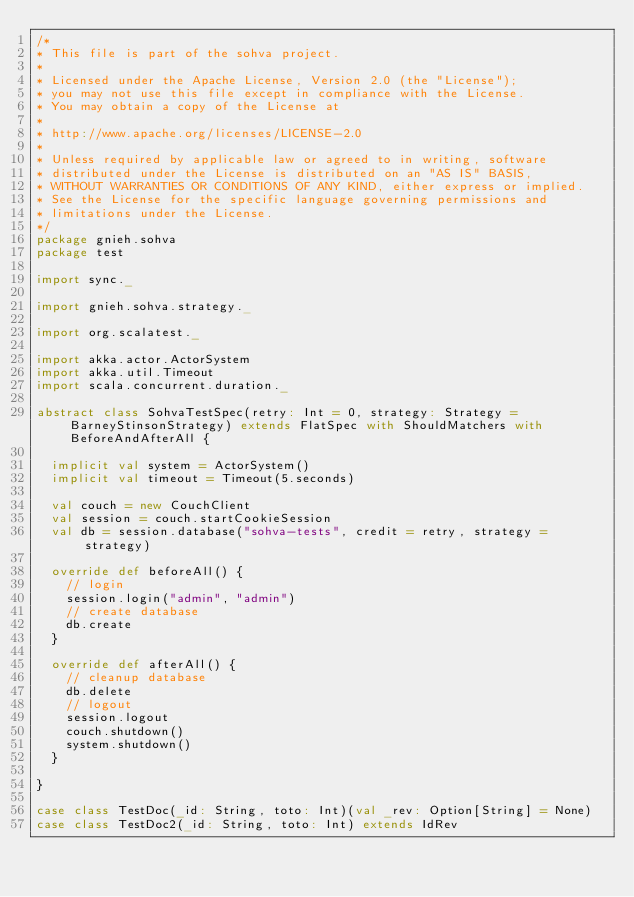Convert code to text. <code><loc_0><loc_0><loc_500><loc_500><_Scala_>/*
* This file is part of the sohva project.
*
* Licensed under the Apache License, Version 2.0 (the "License");
* you may not use this file except in compliance with the License.
* You may obtain a copy of the License at
*
* http://www.apache.org/licenses/LICENSE-2.0
*
* Unless required by applicable law or agreed to in writing, software
* distributed under the License is distributed on an "AS IS" BASIS,
* WITHOUT WARRANTIES OR CONDITIONS OF ANY KIND, either express or implied.
* See the License for the specific language governing permissions and
* limitations under the License.
*/
package gnieh.sohva
package test

import sync._

import gnieh.sohva.strategy._

import org.scalatest._

import akka.actor.ActorSystem
import akka.util.Timeout
import scala.concurrent.duration._

abstract class SohvaTestSpec(retry: Int = 0, strategy: Strategy = BarneyStinsonStrategy) extends FlatSpec with ShouldMatchers with BeforeAndAfterAll {

  implicit val system = ActorSystem()
  implicit val timeout = Timeout(5.seconds)

  val couch = new CouchClient
  val session = couch.startCookieSession
  val db = session.database("sohva-tests", credit = retry, strategy = strategy)

  override def beforeAll() {
    // login
    session.login("admin", "admin")
    // create database
    db.create
  }

  override def afterAll() {
    // cleanup database
    db.delete
    // logout
    session.logout
    couch.shutdown()
    system.shutdown()
  }

}

case class TestDoc(_id: String, toto: Int)(val _rev: Option[String] = None)
case class TestDoc2(_id: String, toto: Int) extends IdRev

</code> 